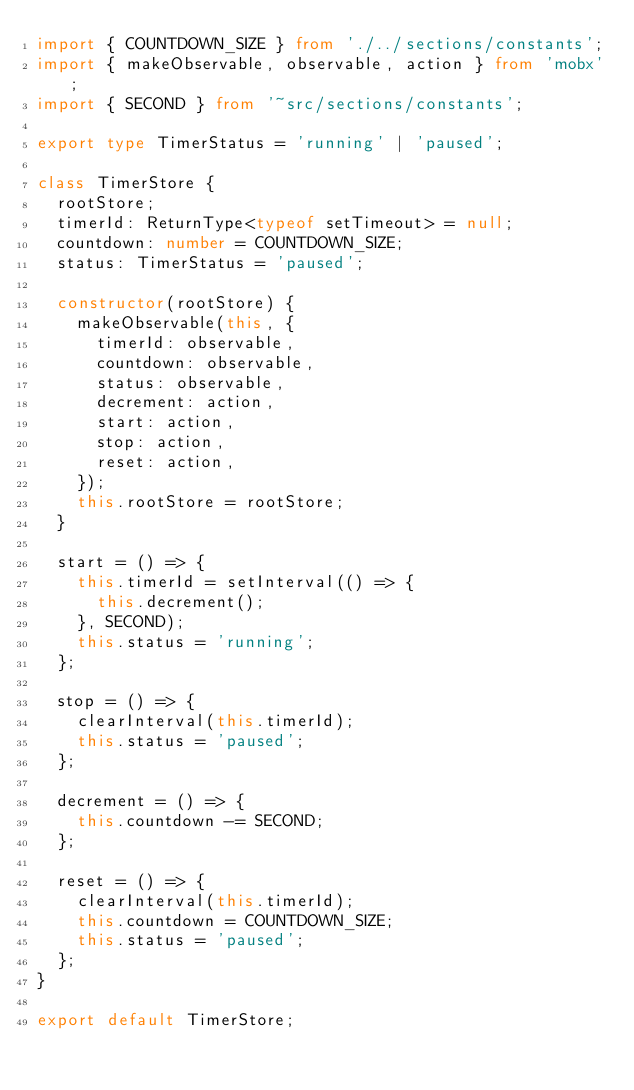Convert code to text. <code><loc_0><loc_0><loc_500><loc_500><_TypeScript_>import { COUNTDOWN_SIZE } from './../sections/constants';
import { makeObservable, observable, action } from 'mobx';
import { SECOND } from '~src/sections/constants';

export type TimerStatus = 'running' | 'paused';

class TimerStore {
  rootStore;
  timerId: ReturnType<typeof setTimeout> = null;
  countdown: number = COUNTDOWN_SIZE;
  status: TimerStatus = 'paused';

  constructor(rootStore) {
    makeObservable(this, {
      timerId: observable,
      countdown: observable,
      status: observable,
      decrement: action,
      start: action,
      stop: action,
      reset: action,
    });
    this.rootStore = rootStore;
  }

  start = () => {
    this.timerId = setInterval(() => {
      this.decrement();
    }, SECOND);
    this.status = 'running';
  };

  stop = () => {
    clearInterval(this.timerId);
    this.status = 'paused';
  };

  decrement = () => {
    this.countdown -= SECOND;
  };

  reset = () => {
    clearInterval(this.timerId);
    this.countdown = COUNTDOWN_SIZE;
    this.status = 'paused';
  };
}

export default TimerStore;
</code> 